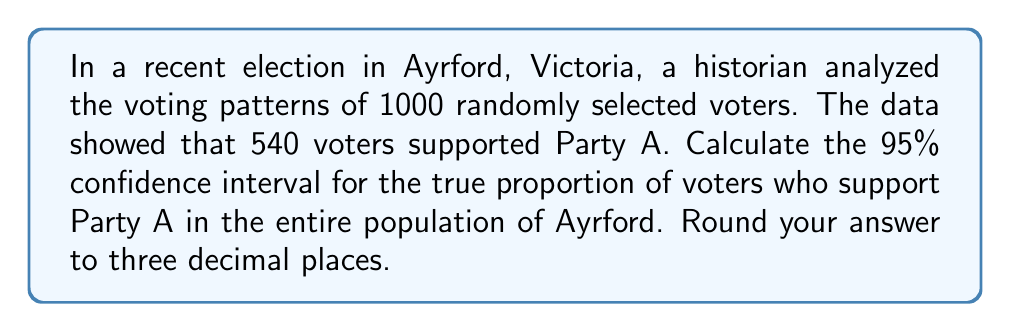Provide a solution to this math problem. To calculate the confidence interval for a proportion, we'll use the following steps:

1. Calculate the sample proportion:
   $\hat{p} = \frac{540}{1000} = 0.54$

2. Calculate the standard error:
   $SE = \sqrt{\frac{\hat{p}(1-\hat{p})}{n}}$
   $SE = \sqrt{\frac{0.54(1-0.54)}{1000}} = 0.01575$

3. For a 95% confidence interval, use a z-score of 1.96 (from the standard normal distribution table).

4. Calculate the margin of error:
   $ME = 1.96 \times SE = 1.96 \times 0.01575 = 0.03087$

5. Calculate the confidence interval:
   $CI = \hat{p} \pm ME$
   $CI = 0.54 \pm 0.03087$

6. Round to three decimal places:
   Lower bound: $0.54 - 0.03087 = 0.50913 \approx 0.509$
   Upper bound: $0.54 + 0.03087 = 0.57087 \approx 0.571$

Therefore, the 95% confidence interval is (0.509, 0.571).
Answer: (0.509, 0.571) 